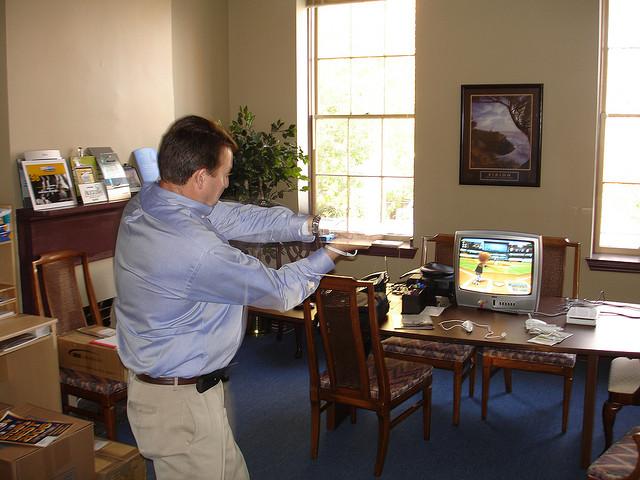What color is the floor?
Be succinct. Blue. What color is his belt?
Write a very short answer. Brown. What sport is he virtually playing?
Short answer required. Baseball. 